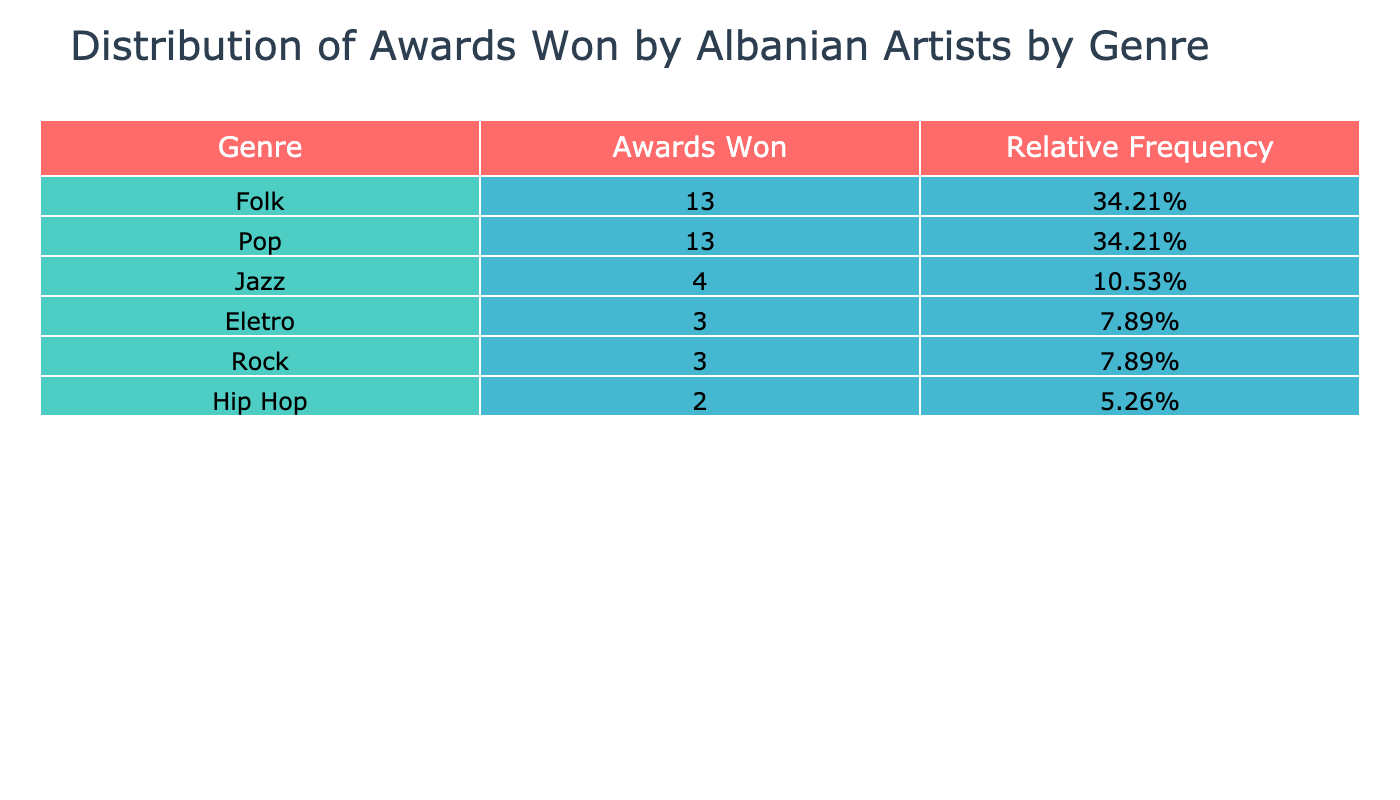What genre has the most awards won? By looking at the table, the Folk genre has the highest total with 13 awards won compared to others.
Answer: Folk Which artist has won the most awards? The artist with the most awards is Vačja, who has won a total of 5 awards in the Folk genre.
Answer: Vačja How many awards have been won by Pop artists in total? The total awards won by Pop artists can be found by adding the awards from Elita 5 (4), Eneda Tarifa (3), Albin Kelmendi (1), Arbana Osmani (3), and Inis (2). This sums up to 4 + 3 + 1 + 3 + 2 = 13.
Answer: 13 Is the statement "Folk artists have fewer awards than Pop artists" true or false? To check this, we compare the total number of awards. Folk artists have 13 awards while Pop artists have 13 awards as well, thus it is false.
Answer: False What is the relative frequency of awards won by Jazz artists? The total awards across all genres is 31 (which is the sum of awards won by all artists). Jazz artists have won 4 awards (Adrian Lulgjuraj with 2 and Ervin Bushaj with 2). Therefore, the relative frequency is 4/31, which is approximately 0.129 or 12.9%.
Answer: 12.9% How does the number of awards won by Hip Hop artists compare to that of Rock artists? Hip Hop artists have won a total of 2 awards (Stresi), while Rock artists have won a total of 3 awards (Bajram Fufi with 2 and Brikena Kelmendi with 1). Therefore, Rock artists won more awards than Hip Hop artists.
Answer: Rock artists have more awards What is the total number of awards won by all artists of the Folk genre? The total awards won by Folk artists can be calculated by adding the individual awards: Vačja (5), Isuf Lutfi (3), Mariza Ikonomi (4), and Arbenita Ismajli (1). This totals to 5 + 3 + 4 + 1 = 13.
Answer: 13 If we combine the awards from both Pop and Folk genres, how many awards do they collectively have? The total awards from Pop is 13 and from Folk is 13. Adding these two totals (13 + 13) gives us 26 awards in total.
Answer: 26 Do any Jazz artists have more than 3 awards? According to the table, both Jazz artists (Adrian Lulgjuraj and Ervin Bushaj) have 2 awards each, meaning there are no Jazz artists with more than 3 awards.
Answer: No 